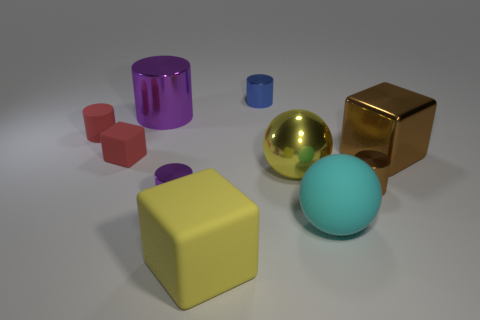What number of other things are there of the same material as the tiny blue object
Make the answer very short. 5. There is a tiny cylinder behind the purple shiny cylinder that is behind the red cylinder; what number of small shiny things are in front of it?
Make the answer very short. 2. How many metallic things are either tiny purple cylinders or large yellow things?
Provide a succinct answer. 2. What size is the block that is to the right of the tiny shiny cylinder that is behind the large purple metallic thing?
Your answer should be very brief. Large. There is a big block that is behind the large yellow shiny thing; is its color the same as the big object behind the big brown metallic thing?
Provide a succinct answer. No. What is the color of the object that is to the right of the large cyan matte thing and in front of the big yellow shiny object?
Offer a very short reply. Brown. Are the tiny red block and the small blue cylinder made of the same material?
Your response must be concise. No. What number of big things are either brown matte cylinders or red things?
Provide a succinct answer. 0. Is there anything else that has the same shape as the blue metal thing?
Provide a succinct answer. Yes. Is there anything else that is the same size as the yellow metallic sphere?
Offer a terse response. Yes. 